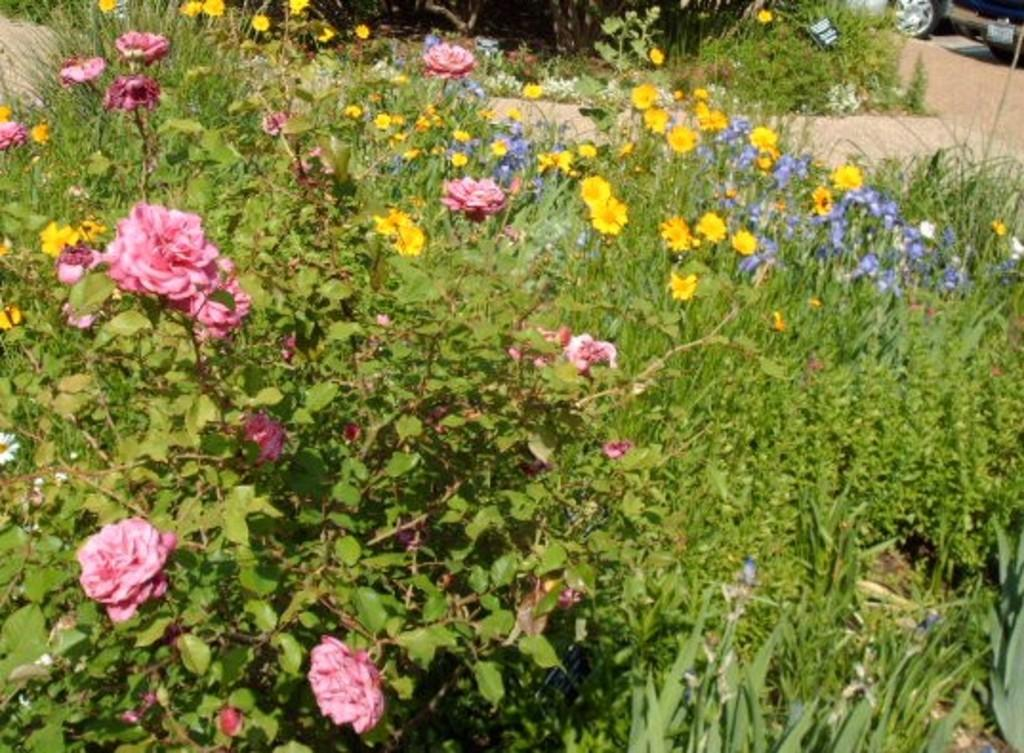What is the main subject in the center of the image? There are plants in the center of the image. What additional features are associated with the plants? There are flowers associated with the plants. What can be seen in the background of the image? There is a road and grass visible in the background of the image. What type of reward can be seen on the toes of the person in the image? There is no person or reward present in the image; it features plants with flowers and a background with a road and grass. 